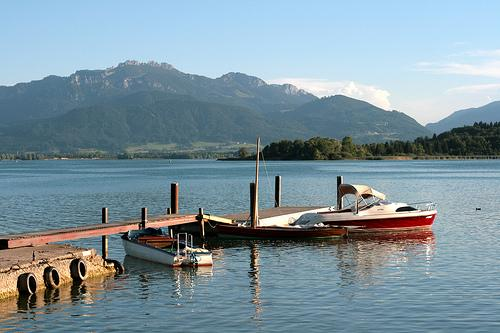Identify the primary elements in the image, and provide a brief description. There are boats docked at a pier, calm water with reflections, a boardwalk, trees, mountains, and a white cloud above the mountaintop. What kind of advertisement could be based on this image? Provide a brief description. A travel agency advertisement promoting peaceful and serene vacation destinations near water, mountains, and forests for relaxation and outdoor activities. How could this image be used for a multi-choice VQA task? Give a brief example. Correct Answer: C) Docked boats Comment on the state of the water in the image. The water is calm and smooth, creating clear reflections on the surface. 